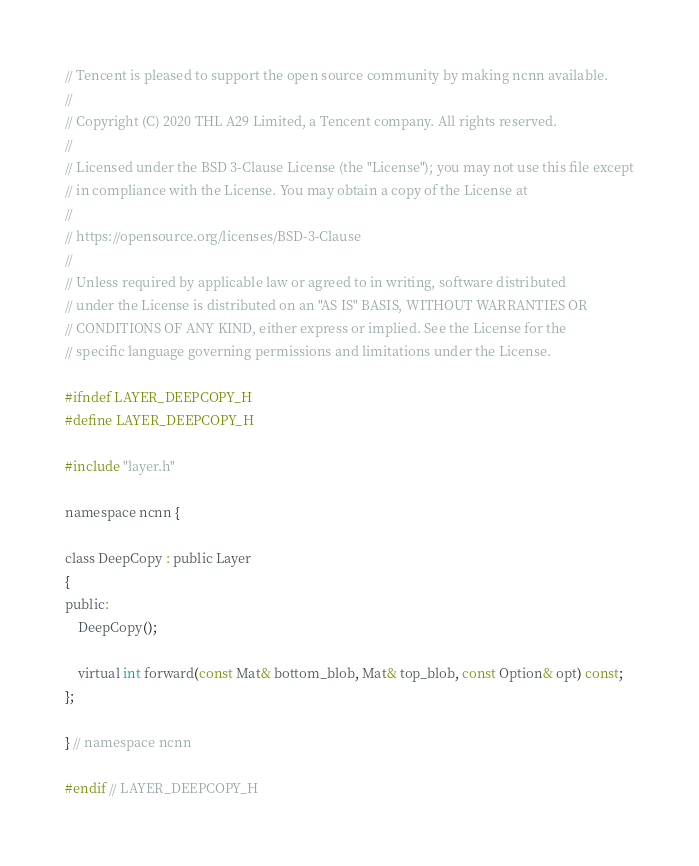Convert code to text. <code><loc_0><loc_0><loc_500><loc_500><_C_>// Tencent is pleased to support the open source community by making ncnn available.
//
// Copyright (C) 2020 THL A29 Limited, a Tencent company. All rights reserved.
//
// Licensed under the BSD 3-Clause License (the "License"); you may not use this file except
// in compliance with the License. You may obtain a copy of the License at
//
// https://opensource.org/licenses/BSD-3-Clause
//
// Unless required by applicable law or agreed to in writing, software distributed
// under the License is distributed on an "AS IS" BASIS, WITHOUT WARRANTIES OR
// CONDITIONS OF ANY KIND, either express or implied. See the License for the
// specific language governing permissions and limitations under the License.

#ifndef LAYER_DEEPCOPY_H
#define LAYER_DEEPCOPY_H

#include "layer.h"

namespace ncnn {

class DeepCopy : public Layer
{
public:
    DeepCopy();

    virtual int forward(const Mat& bottom_blob, Mat& top_blob, const Option& opt) const;
};

} // namespace ncnn

#endif // LAYER_DEEPCOPY_H
</code> 